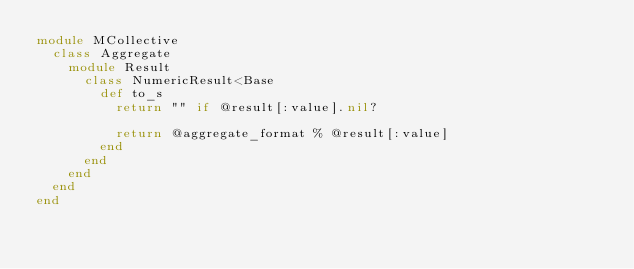Convert code to text. <code><loc_0><loc_0><loc_500><loc_500><_Ruby_>module MCollective
  class Aggregate
    module Result
      class NumericResult<Base
        def to_s
          return "" if @result[:value].nil?

          return @aggregate_format % @result[:value]
        end
      end
    end
  end
end
</code> 